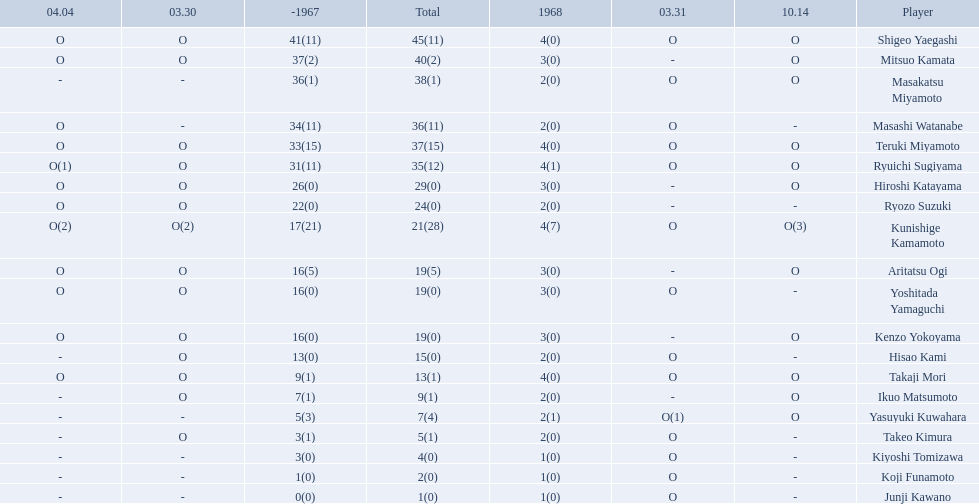Who were the players in the 1968 japanese football? Shigeo Yaegashi, Mitsuo Kamata, Masakatsu Miyamoto, Masashi Watanabe, Teruki Miyamoto, Ryuichi Sugiyama, Hiroshi Katayama, Ryozo Suzuki, Kunishige Kamamoto, Aritatsu Ogi, Yoshitada Yamaguchi, Kenzo Yokoyama, Hisao Kami, Takaji Mori, Ikuo Matsumoto, Yasuyuki Kuwahara, Takeo Kimura, Kiyoshi Tomizawa, Koji Funamoto, Junji Kawano. How many points total did takaji mori have? 13(1). How many points total did junju kawano? 1(0). Who had more points? Takaji Mori. 